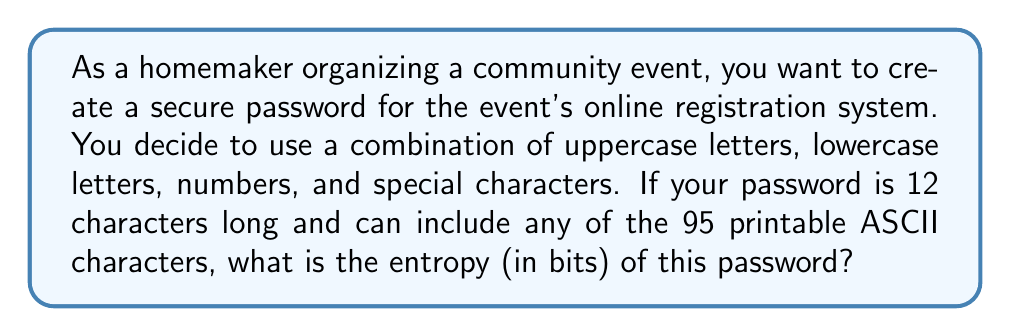Can you answer this question? To calculate the entropy of a password, we use the formula:

$$ E = L \times \log_2(R) $$

Where:
$E$ = Entropy (in bits)
$L$ = Length of the password
$R$ = Range of possible characters

Step 1: Determine the values
$L = 12$ (given in the question)
$R = 95$ (95 printable ASCII characters)

Step 2: Apply the formula
$$ E = 12 \times \log_2(95) $$

Step 3: Calculate $\log_2(95)$
$\log_2(95) \approx 6.57$ (rounded to 2 decimal places)

Step 4: Multiply by the length
$$ E = 12 \times 6.57 $$
$$ E \approx 78.84 \text{ bits} $$

Step 5: Round to the nearest whole number
$$ E \approx 79 \text{ bits} $$

This entropy value indicates a very strong password, suitable for securing important information like event registration details.
Answer: 79 bits 